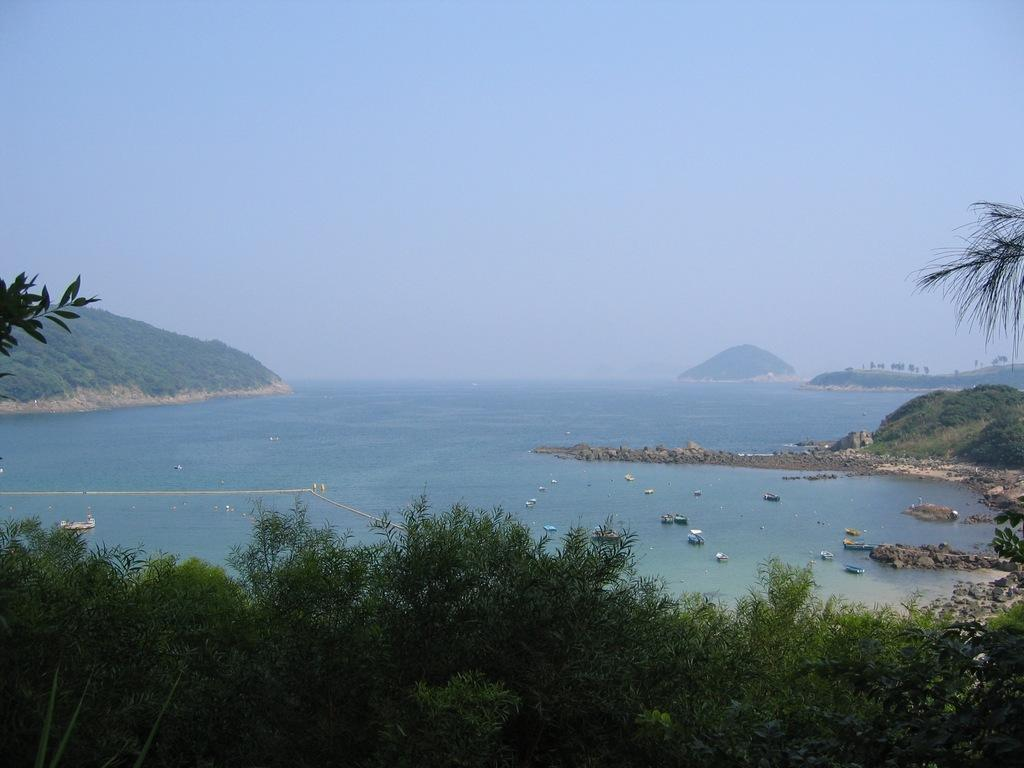What type of natural features can be seen in the image? There are trees and mountains visible in the image. What body of water is present in the image? There is water visible in the image. What type of vehicles are in the image? There are boats in the image. What is visible at the top of the image? The sky is visible at the top of the image. How many cherries are hanging from the trees in the image? There are no cherries visible in the image; only trees are present. What type of trick can be performed with the thread in the image? There is no thread present in the image, so no trick can be performed. 